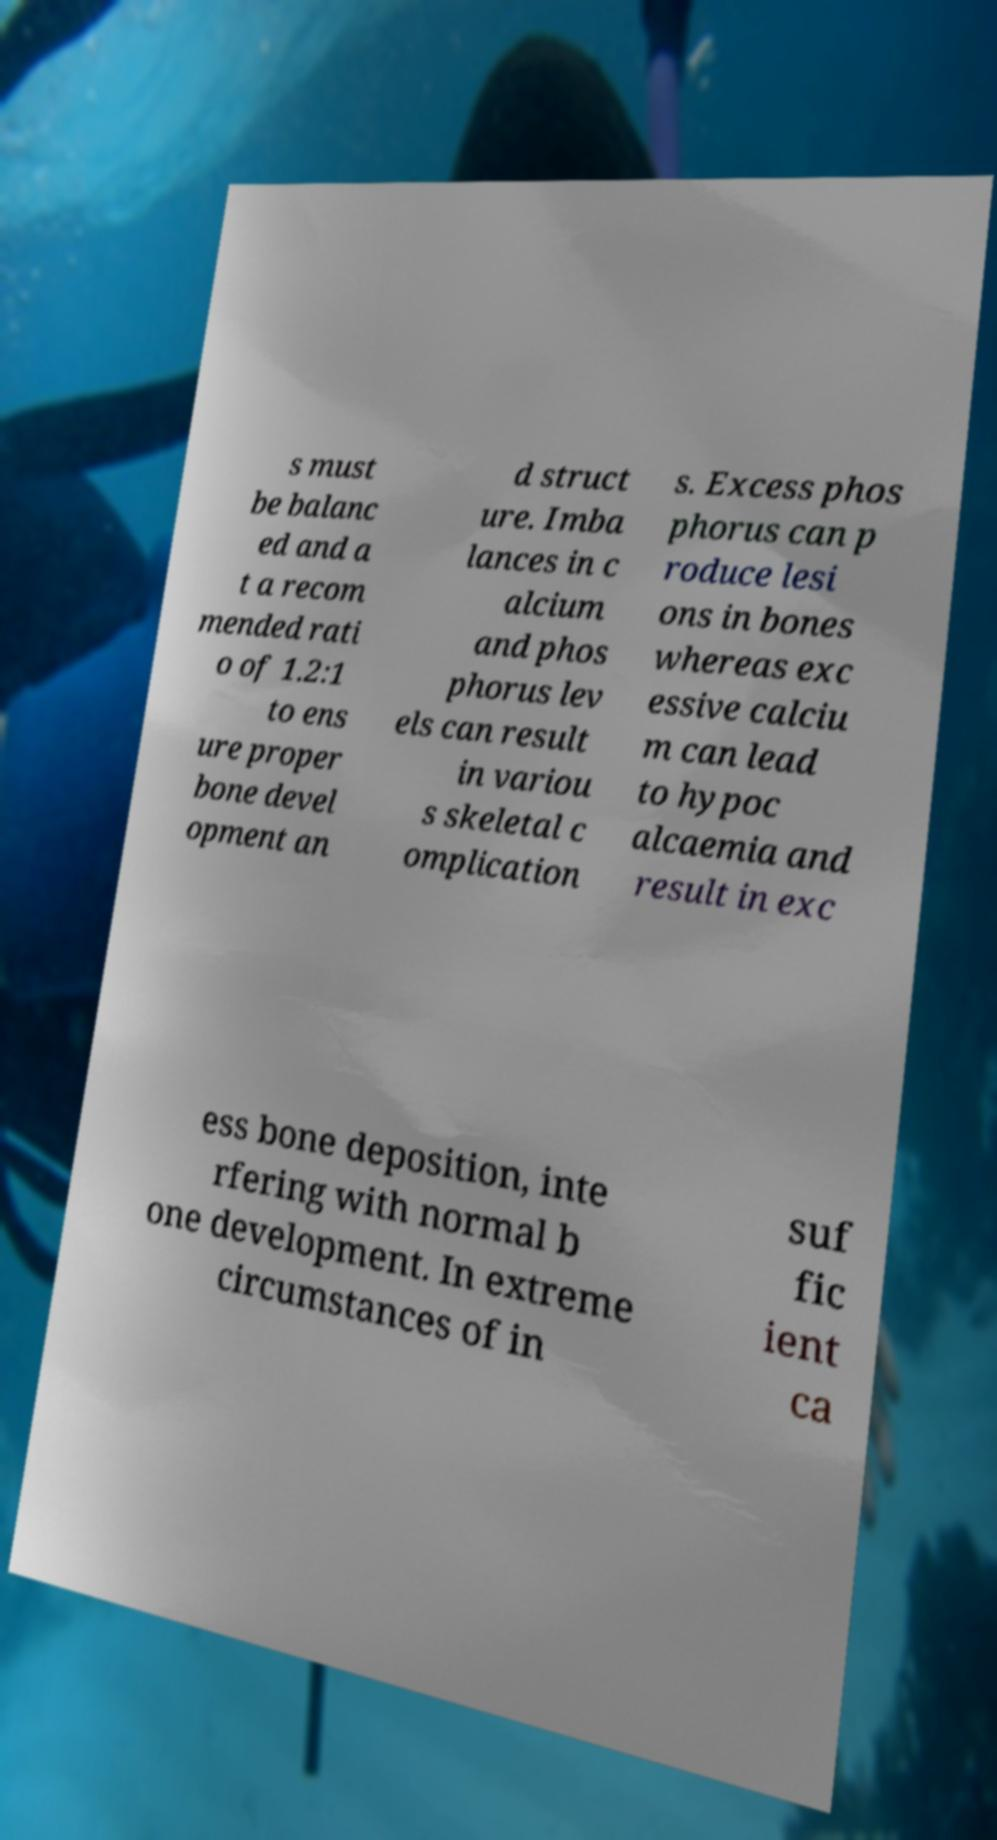Please identify and transcribe the text found in this image. s must be balanc ed and a t a recom mended rati o of 1.2:1 to ens ure proper bone devel opment an d struct ure. Imba lances in c alcium and phos phorus lev els can result in variou s skeletal c omplication s. Excess phos phorus can p roduce lesi ons in bones whereas exc essive calciu m can lead to hypoc alcaemia and result in exc ess bone deposition, inte rfering with normal b one development. In extreme circumstances of in suf fic ient ca 